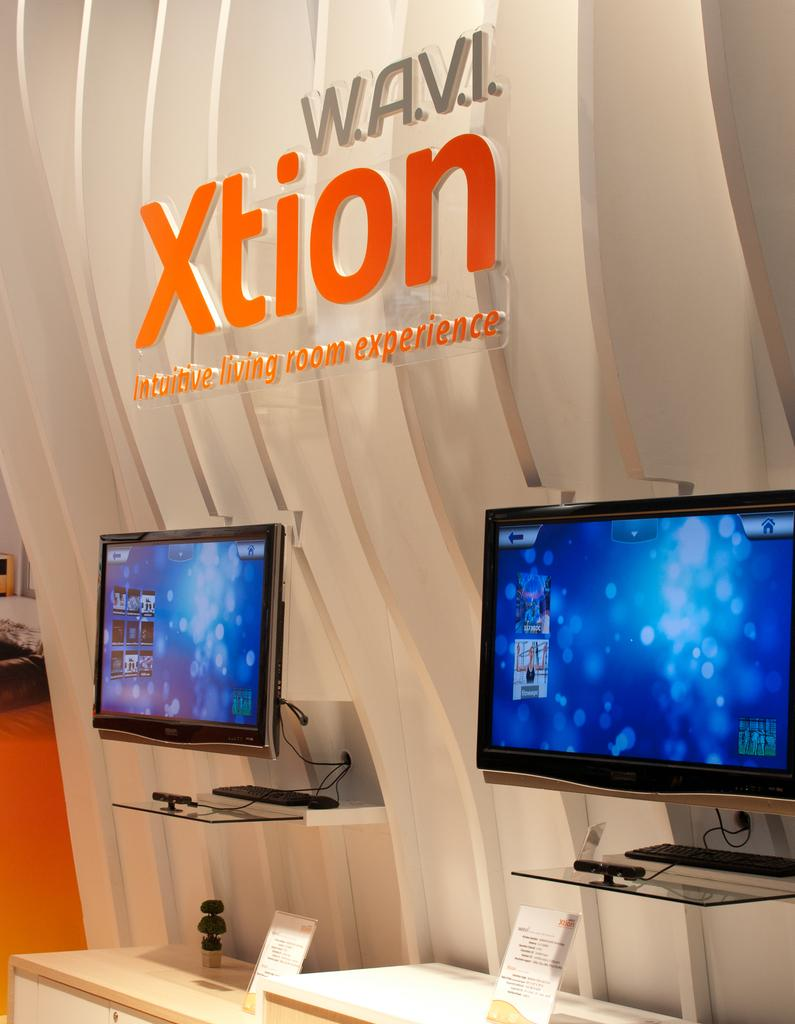Provide a one-sentence caption for the provided image. Computer monitors are on display for a Xtion experience booth. 